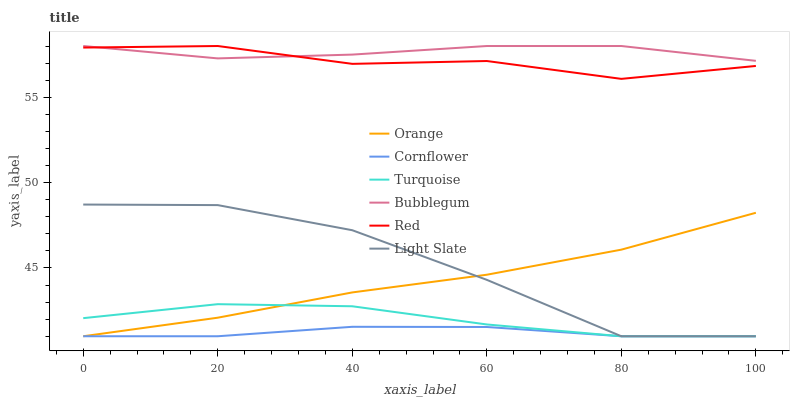Does Cornflower have the minimum area under the curve?
Answer yes or no. Yes. Does Bubblegum have the maximum area under the curve?
Answer yes or no. Yes. Does Turquoise have the minimum area under the curve?
Answer yes or no. No. Does Turquoise have the maximum area under the curve?
Answer yes or no. No. Is Orange the smoothest?
Answer yes or no. Yes. Is Light Slate the roughest?
Answer yes or no. Yes. Is Turquoise the smoothest?
Answer yes or no. No. Is Turquoise the roughest?
Answer yes or no. No. Does Cornflower have the lowest value?
Answer yes or no. Yes. Does Bubblegum have the lowest value?
Answer yes or no. No. Does Red have the highest value?
Answer yes or no. Yes. Does Turquoise have the highest value?
Answer yes or no. No. Is Light Slate less than Bubblegum?
Answer yes or no. Yes. Is Bubblegum greater than Light Slate?
Answer yes or no. Yes. Does Cornflower intersect Turquoise?
Answer yes or no. Yes. Is Cornflower less than Turquoise?
Answer yes or no. No. Is Cornflower greater than Turquoise?
Answer yes or no. No. Does Light Slate intersect Bubblegum?
Answer yes or no. No. 